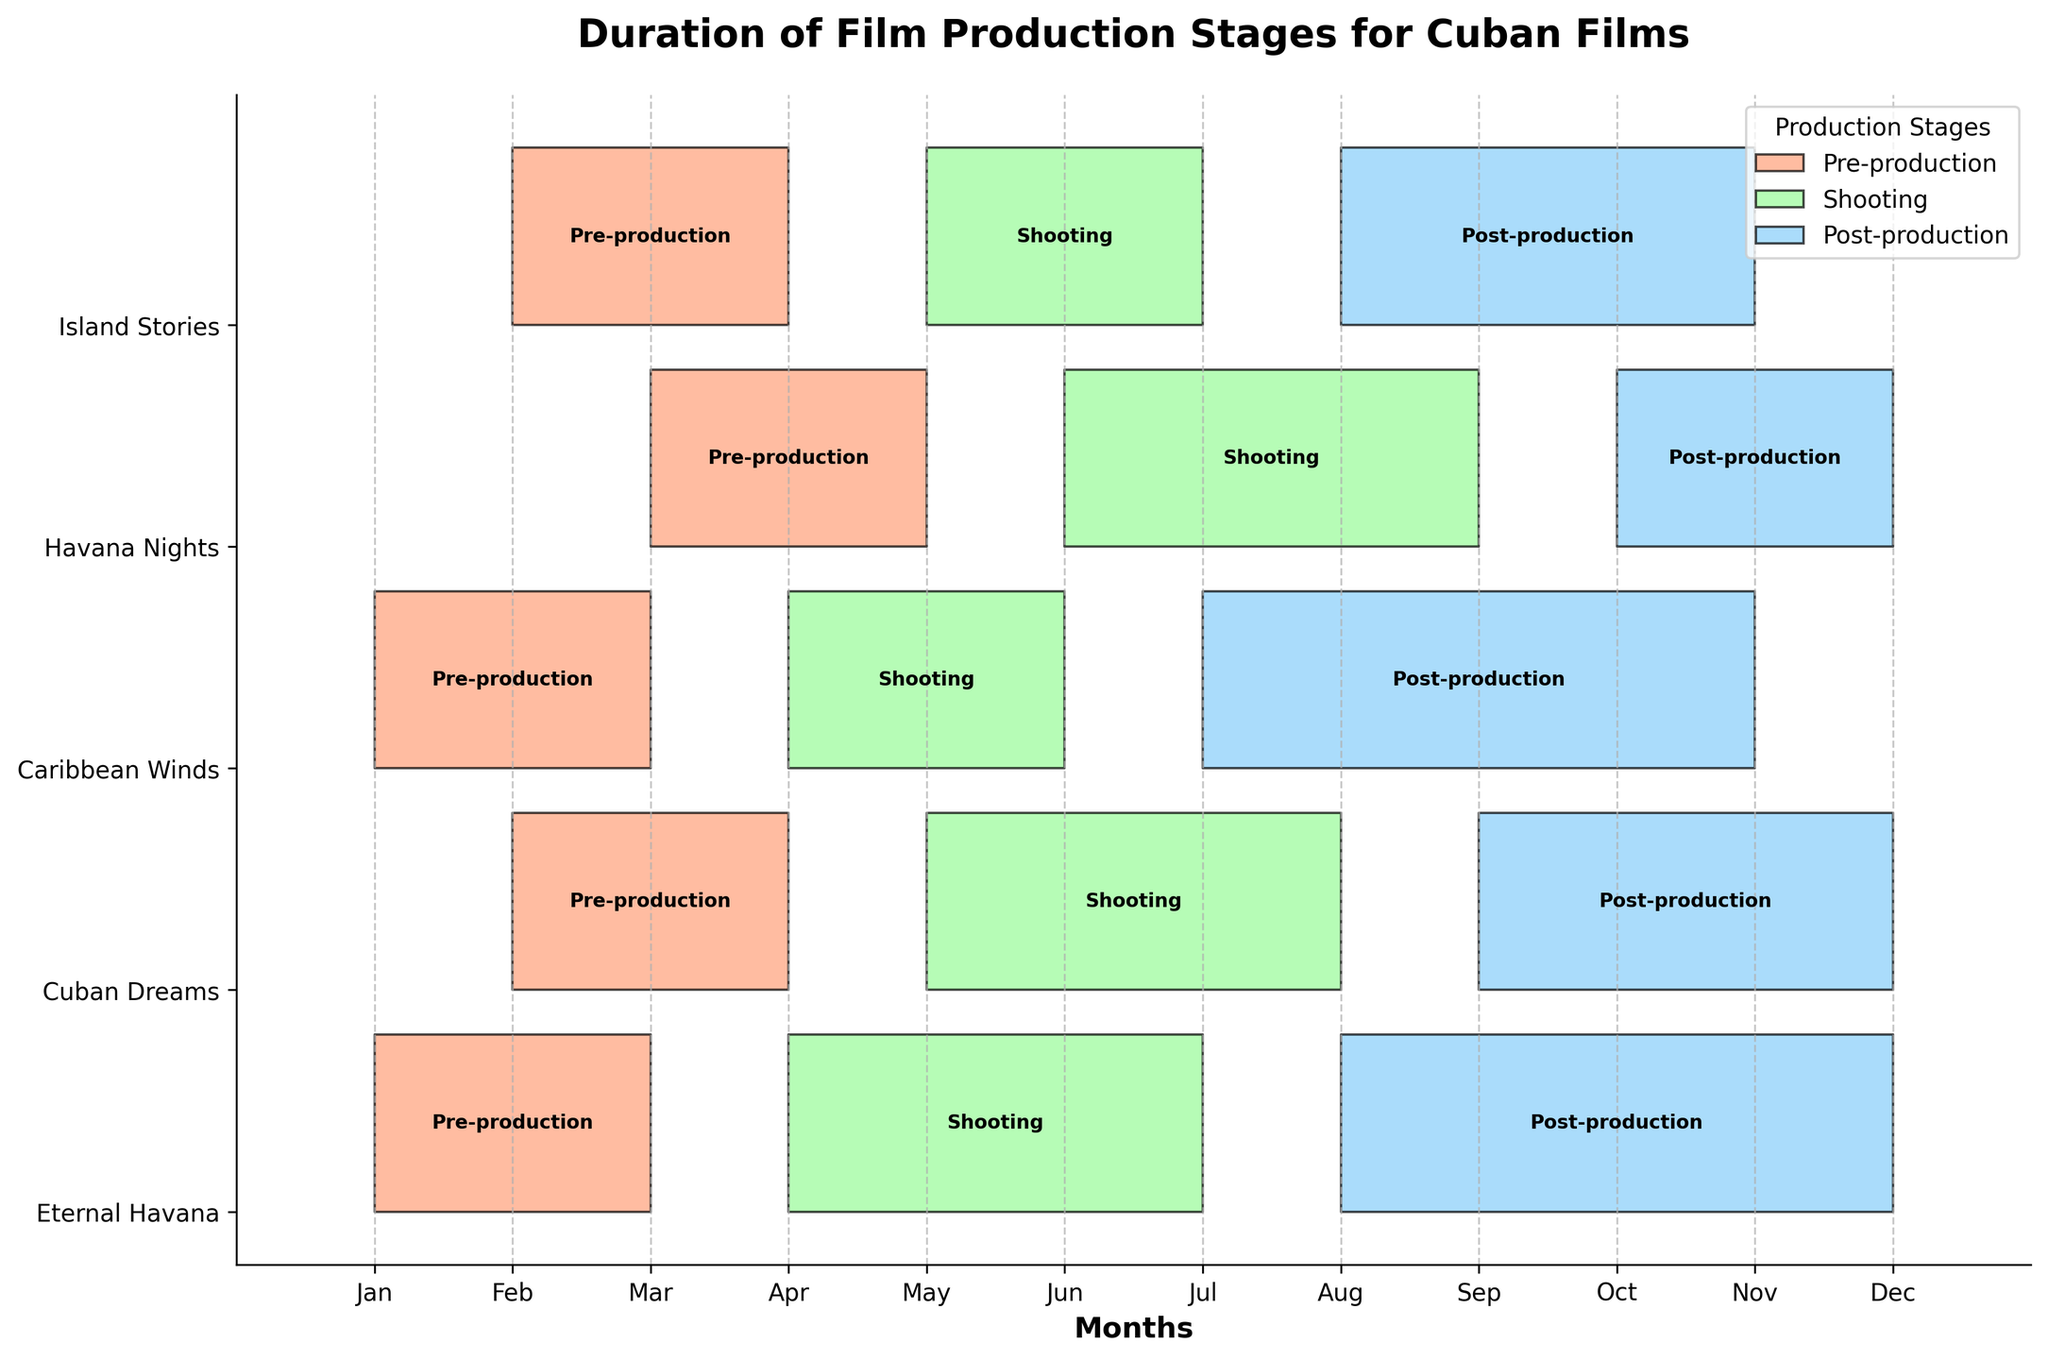What's the title of the figure? The title is displayed at the top of the figure. By reading it, we see it says "Duration of Film Production Stages for Cuban Films."
Answer: Duration of Film Production Stages for Cuban Films Which film has the longest Post-production stage? Look at the Post-production stages (colored in light blue) for all films. Identify the one that spans the most months. "Eternal Havana" spans from month 8 to 12 (5 months).
Answer: Eternal Havana During which months does "Havana Nights" have its Shooting stage? Find "Havana Nights" on the y-axis and look at the Shooting stage bar (colored in light green). It starts at month 6 and ends at month 9.
Answer: June to September Which film had the shortest Pre-production stage? Compare the Pre-production stages (colored in light coral) for all films. They all span 3 months except "Island Stories" and "Cuban Dreams," which span from month 2 to 4 (3 months).
Answer: Island Stories and Cuban Dreams On average, how long is the Pre-production stage across all films? Calculate the duration of the Pre-production stage for each film: (3, 3, 3, 3, 3). The average is (3+3+3+3+3)/5 = 3 months.
Answer: 3 months Which two films have overlapping Shooting stages? Look at the Shooting stages (colored in light green) and find the films with overlapping bars. "Eternal Havana" (4-7) overlaps with "Cuban Dreams" (5-8), and both overlap with "Caribbean Winds" (4-6). "Island Stories" (5-7) also overlaps with all three.
Answer: Eternal Havana, Cuban Dreams, Caribbean Winds, Island Stories How many films start their Pre-production stage in January? Observe the bars for Pre-production starting in January. "Eternal Havana" and "Caribbean Winds" are the films starting in January.
Answer: 2 films Which production stage starts first for "Island Stories"? Look at the three stages of "Island Stories" and check the start months. The Pre-production stage starts first in month 2.
Answer: Pre-production What's the total duration of all three stages for "Caribbean Winds"? Sum the durations of Pre-production (3 months from Jan to Mar), Shooting (3 months from Apr to Jun), and Post-production (5 months from Jul to Nov) for "Caribbean Winds." Total duration = 3 + 3 + 5 = 11 months.
Answer: 11 months During which months does "Cuban Dreams" have any of its production stages? Check the timeline for "Cuban Dreams"; it's engaged in Pre-production (Feb-Apr), Shooting (May-Aug), and Post-production (Sep-Dec), which covers months from February to December.
Answer: February to December 